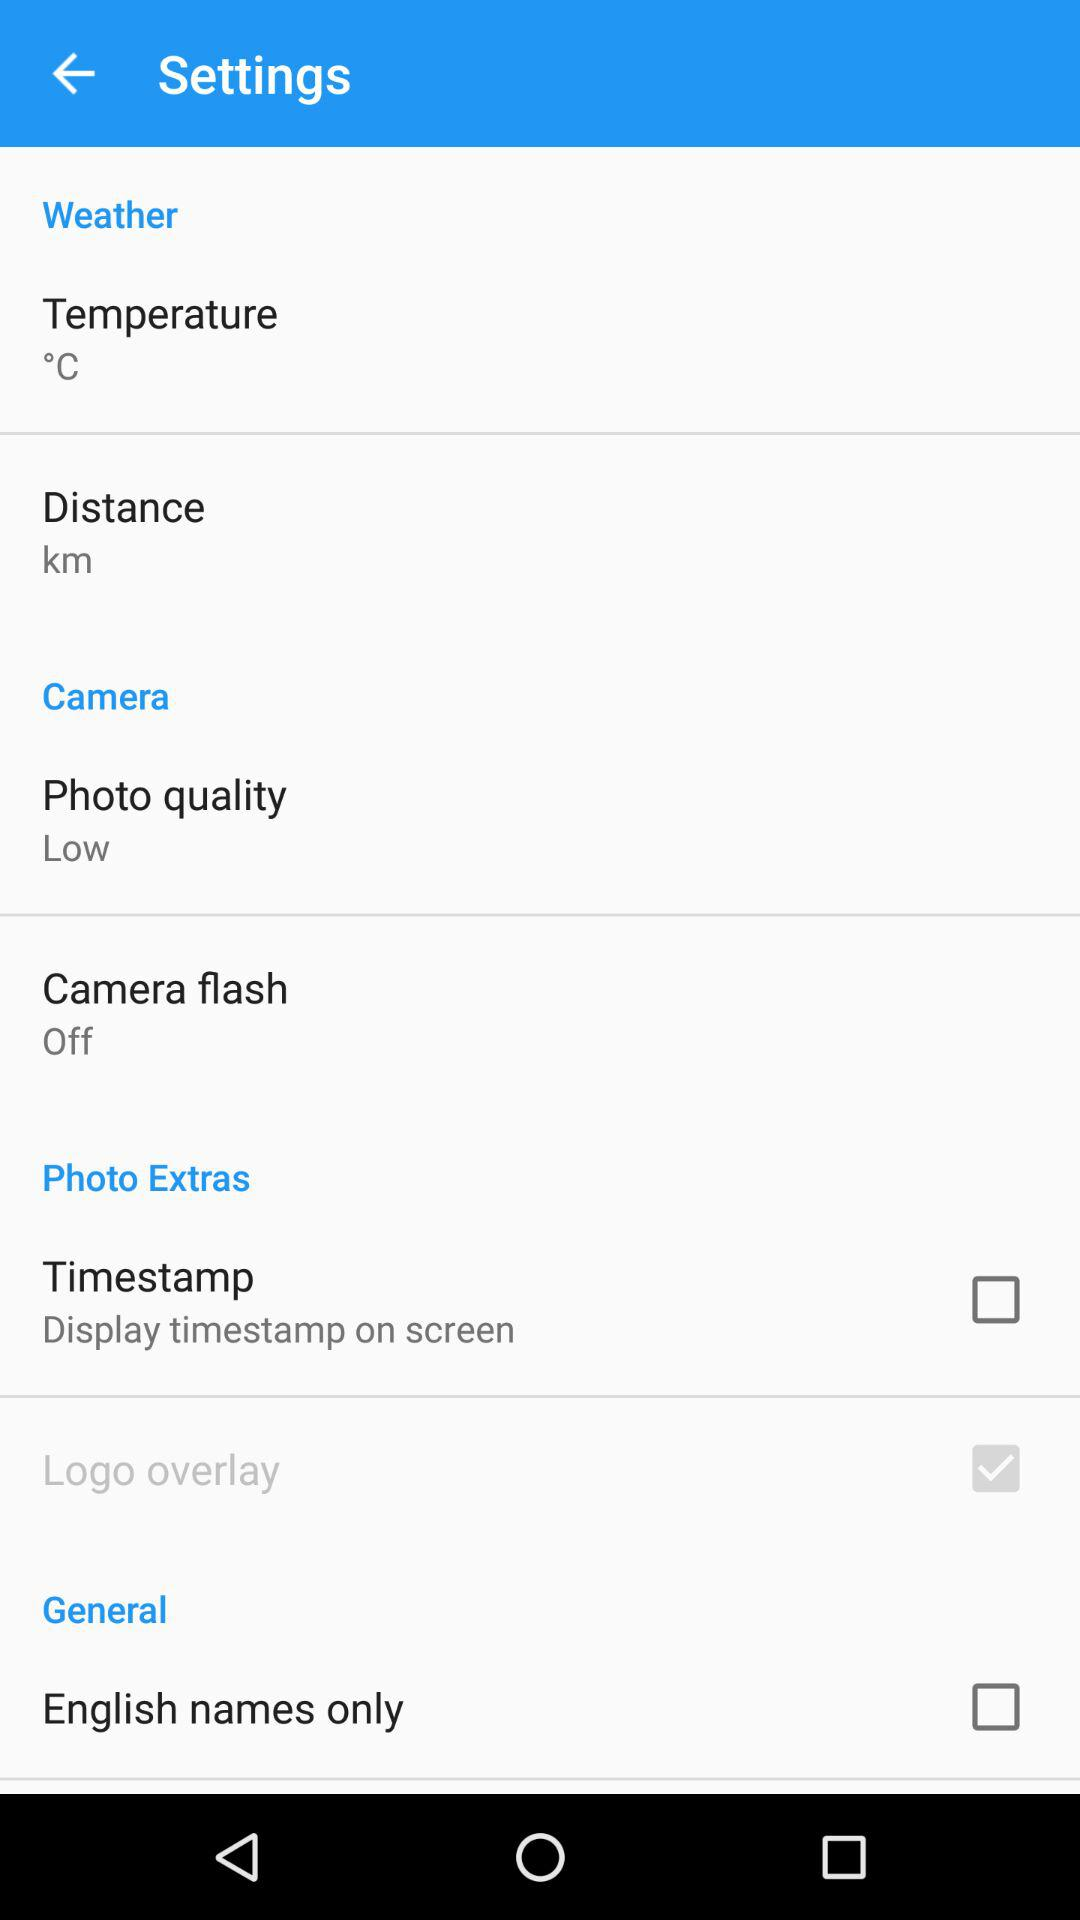What's the selected measuring unit of distance? The selected measuring unit of distance is km. 